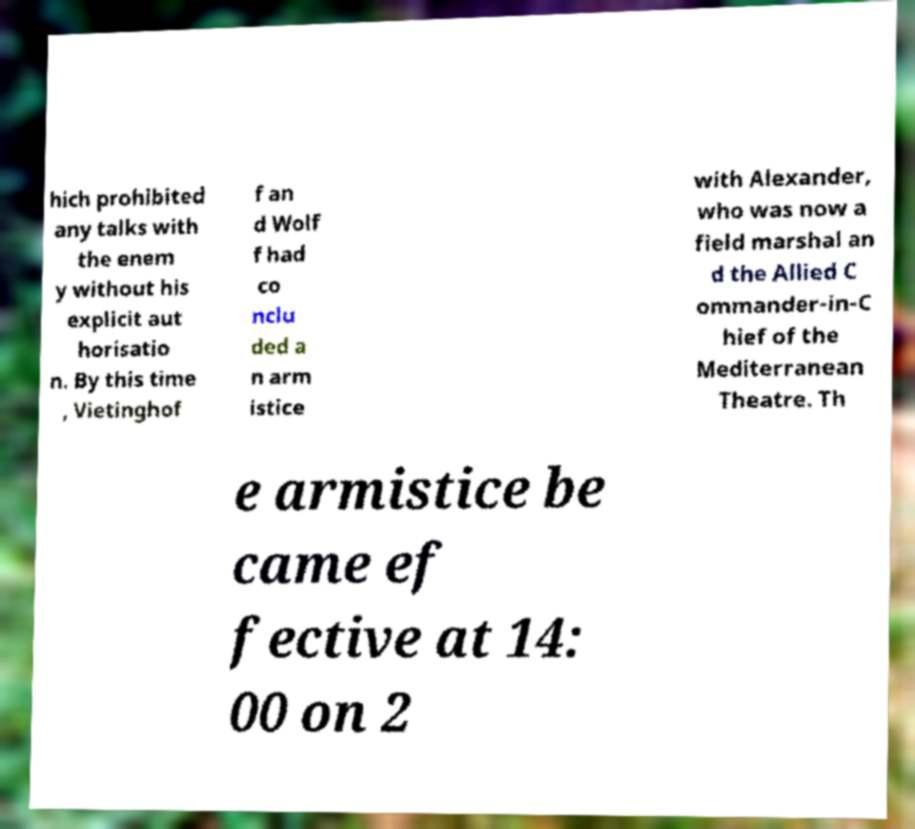For documentation purposes, I need the text within this image transcribed. Could you provide that? hich prohibited any talks with the enem y without his explicit aut horisatio n. By this time , Vietinghof f an d Wolf f had co nclu ded a n arm istice with Alexander, who was now a field marshal an d the Allied C ommander-in-C hief of the Mediterranean Theatre. Th e armistice be came ef fective at 14: 00 on 2 